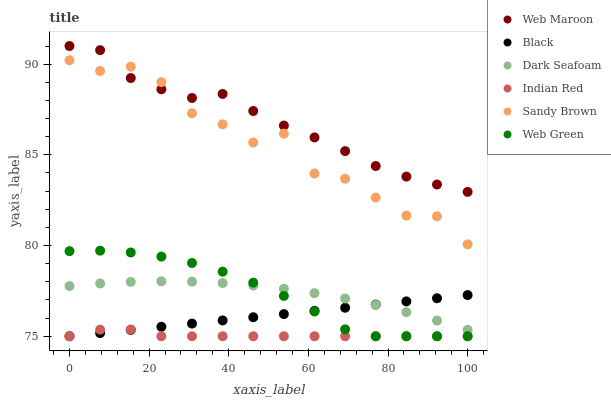Does Indian Red have the minimum area under the curve?
Answer yes or no. Yes. Does Web Maroon have the maximum area under the curve?
Answer yes or no. Yes. Does Web Green have the minimum area under the curve?
Answer yes or no. No. Does Web Green have the maximum area under the curve?
Answer yes or no. No. Is Black the smoothest?
Answer yes or no. Yes. Is Sandy Brown the roughest?
Answer yes or no. Yes. Is Web Green the smoothest?
Answer yes or no. No. Is Web Green the roughest?
Answer yes or no. No. Does Web Green have the lowest value?
Answer yes or no. Yes. Does Dark Seafoam have the lowest value?
Answer yes or no. No. Does Web Maroon have the highest value?
Answer yes or no. Yes. Does Web Green have the highest value?
Answer yes or no. No. Is Black less than Web Maroon?
Answer yes or no. Yes. Is Dark Seafoam greater than Indian Red?
Answer yes or no. Yes. Does Indian Red intersect Web Green?
Answer yes or no. Yes. Is Indian Red less than Web Green?
Answer yes or no. No. Is Indian Red greater than Web Green?
Answer yes or no. No. Does Black intersect Web Maroon?
Answer yes or no. No. 